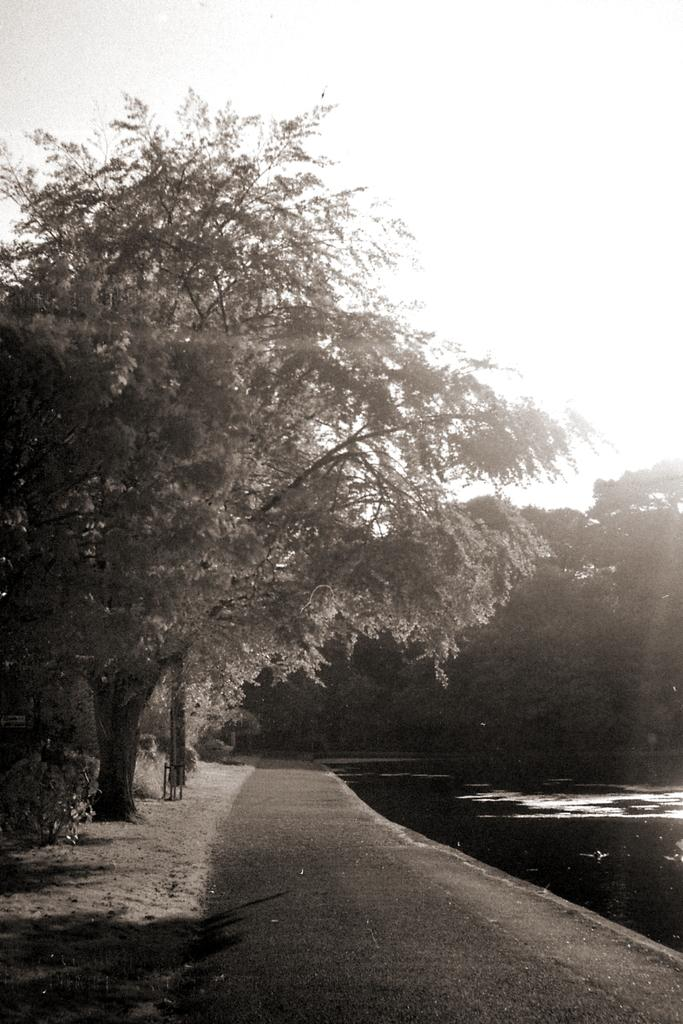What body of water is present in the image? There is a lake in the image. What is located near the lake? There is a road beside the lake. What type of vegetation can be seen on the left side of the image? There are trees on the left side of the image. What can be seen in the background of the image? There are trees visible in the background of the image. What type of oil can be seen floating on the lake in the image? There is no oil present in the image; the lake appears to be clear and free of any contaminants. 